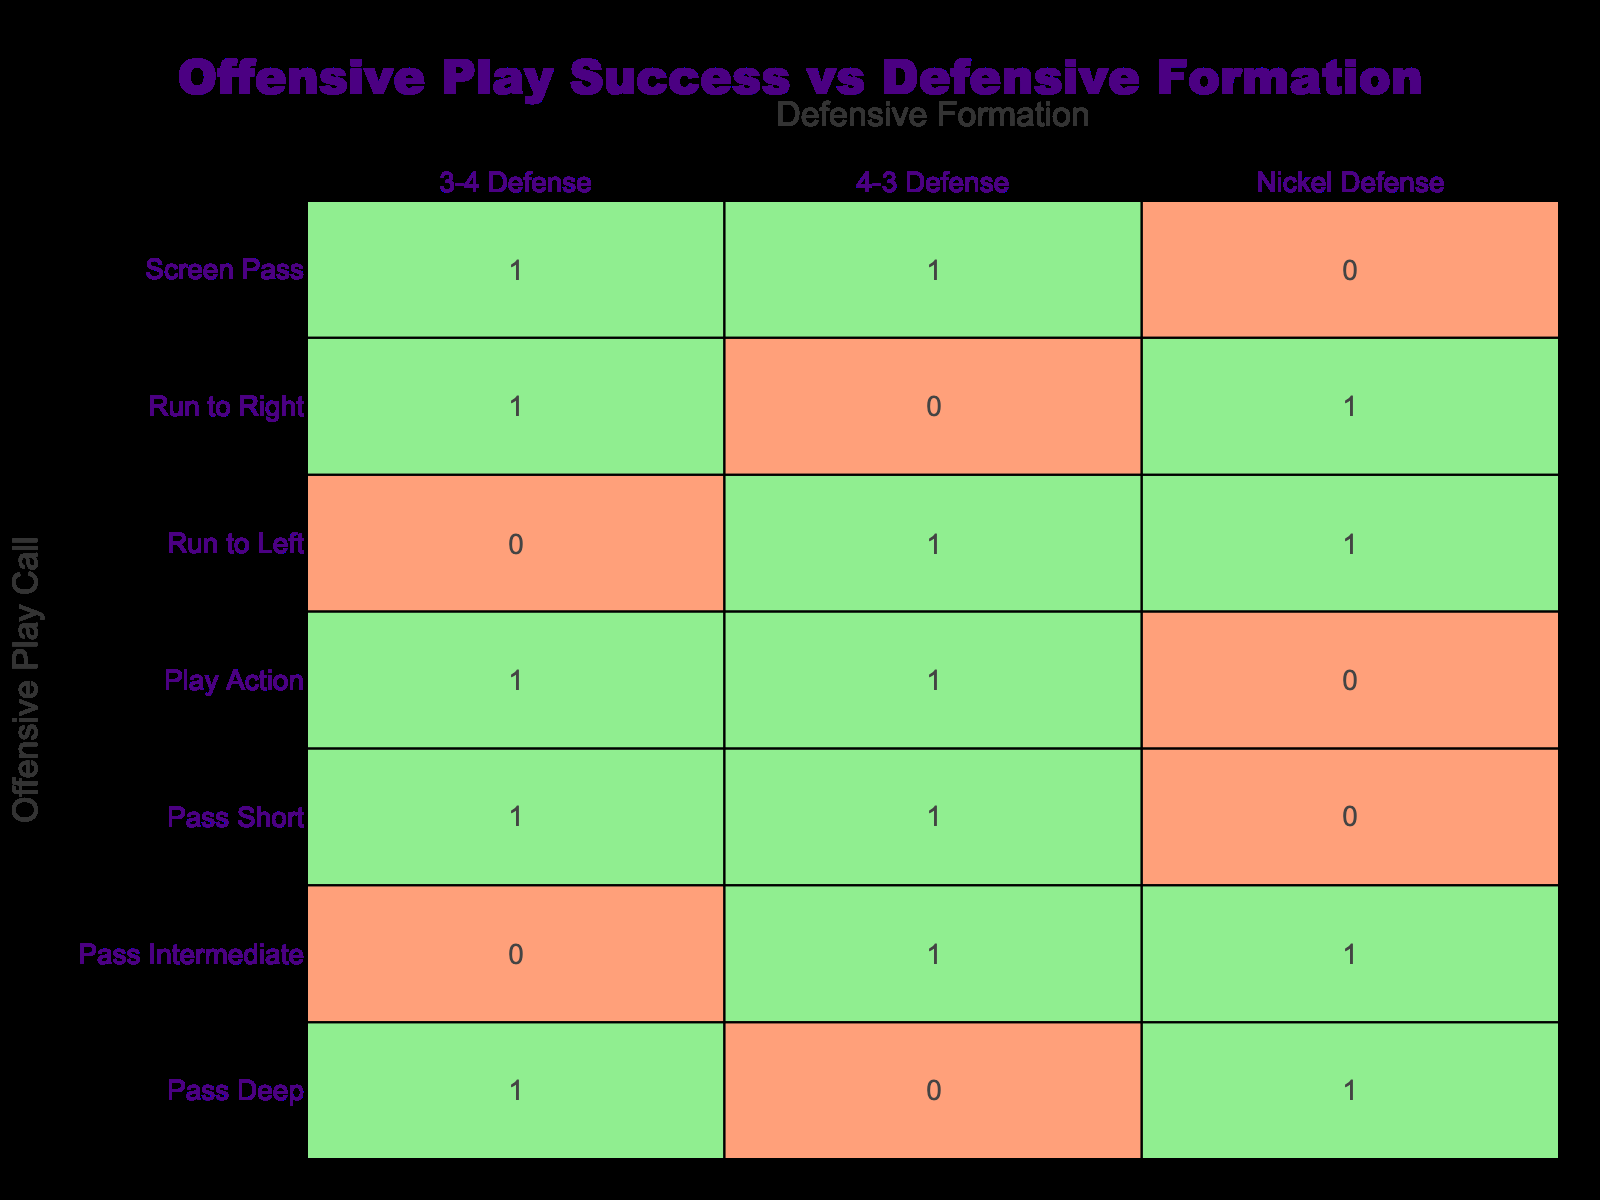What is the success rate of "Run to Left" against "4-3 Defense"? The table shows that the success value for "Run to Left" against "4-3 Defense" is 1. This indicates that there was a successful play when this combination was called.
Answer: 1 What is the total number of successful plays when using "Pass Deep"? To find this, we check the success values for "Pass Deep" across all defensive formations. Success values are 0 (for 4-3 Defense), 1 (for 3-4 Defense), and 1 (for Nickel Defense). Adding these gives us 0 + 1 + 1 = 2 successful plays.
Answer: 2 Did the "Screen Pass" succeed against Nickel Defense? Looking at the table, the success value for "Screen Pass" against "Nickel Defense" is 0. This indicates that there were no successful plays when this combination was called.
Answer: No Which offensive play call had the highest success rate against the "3-4 Defense"? By examining the table, we see that "Run to Right", "Pass Short", and "Play Action" all have success values of 1 against "3-4 Defense". To determine the highest success rate, we note that they are all tied in this case with a success value of 1.
Answer: Run to Right, Pass Short, Play Action What is the average success rate for "Pass" plays across all defensive formations? To calculate the average success rate, we need to identify the three categories of "Pass" plays ("Pass Short", "Pass Intermediate", "Pass Deep") and sum their success rates: 1 (Short) + 0 (Intermediate) + 1 (Deep) = 2 successful plays. There are a total of 3 Pass plays, so the average is 2 / 3 = 0.67.
Answer: 0.67 